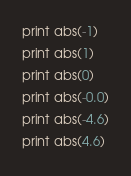Convert code to text. <code><loc_0><loc_0><loc_500><loc_500><_Python_>print abs(-1)
print abs(1)
print abs(0)
print abs(-0.0)
print abs(-4.6)
print abs(4.6)
</code> 